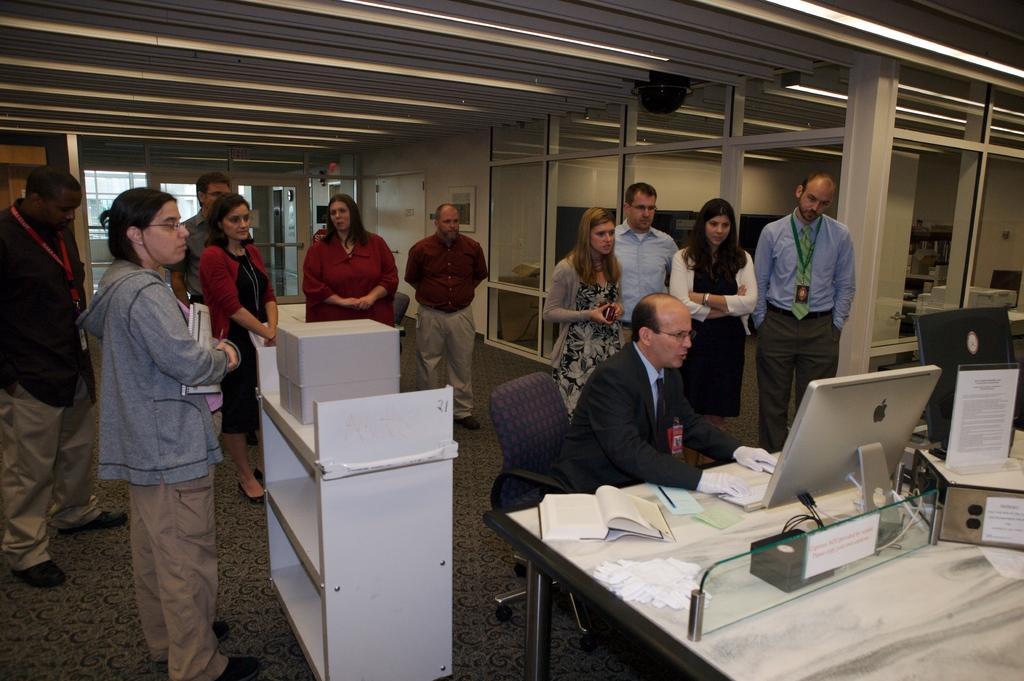Can you describe this image briefly? In this image I see a man who is sitting on the chair and there are lot of people behind him. I also see that there is a table over here and there are lot of things on it. In the background I see the wall. 